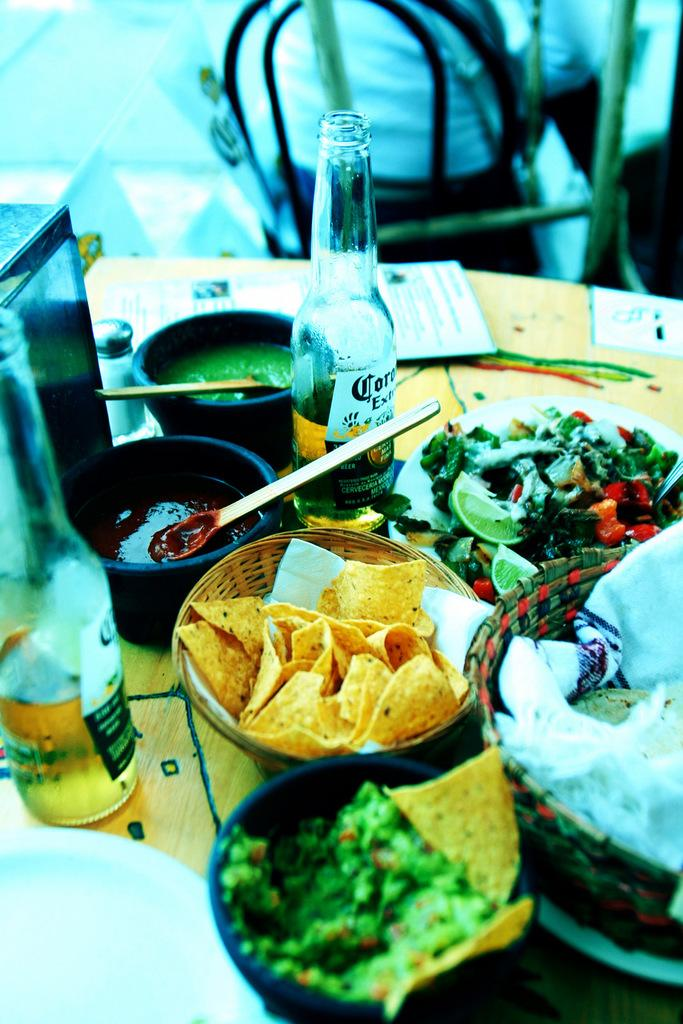What piece of furniture is present in the image? There is a table in the image. What objects are placed on the table? There are bowls and bottles on the table. How many bowls are visible on the table? The number of bowls is not specified in the facts, so it cannot be determined from the information provided. How does the crowd affect the digestion of the food in the image? There is no crowd present in the image, and therefore no impact on the digestion of the food can be observed. 